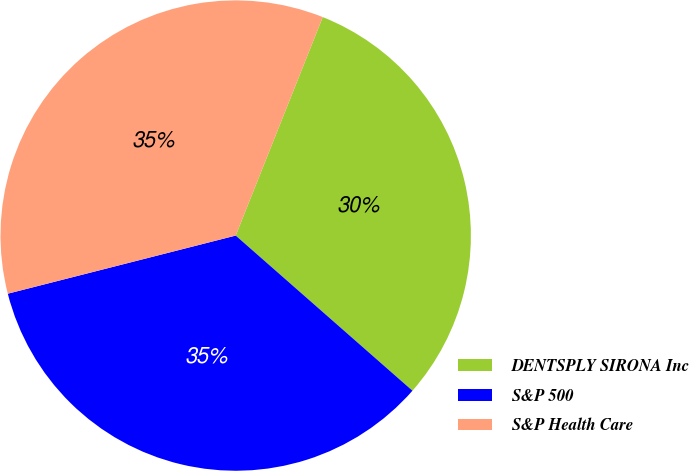Convert chart. <chart><loc_0><loc_0><loc_500><loc_500><pie_chart><fcel>DENTSPLY SIRONA Inc<fcel>S&P 500<fcel>S&P Health Care<nl><fcel>30.43%<fcel>34.56%<fcel>35.01%<nl></chart> 